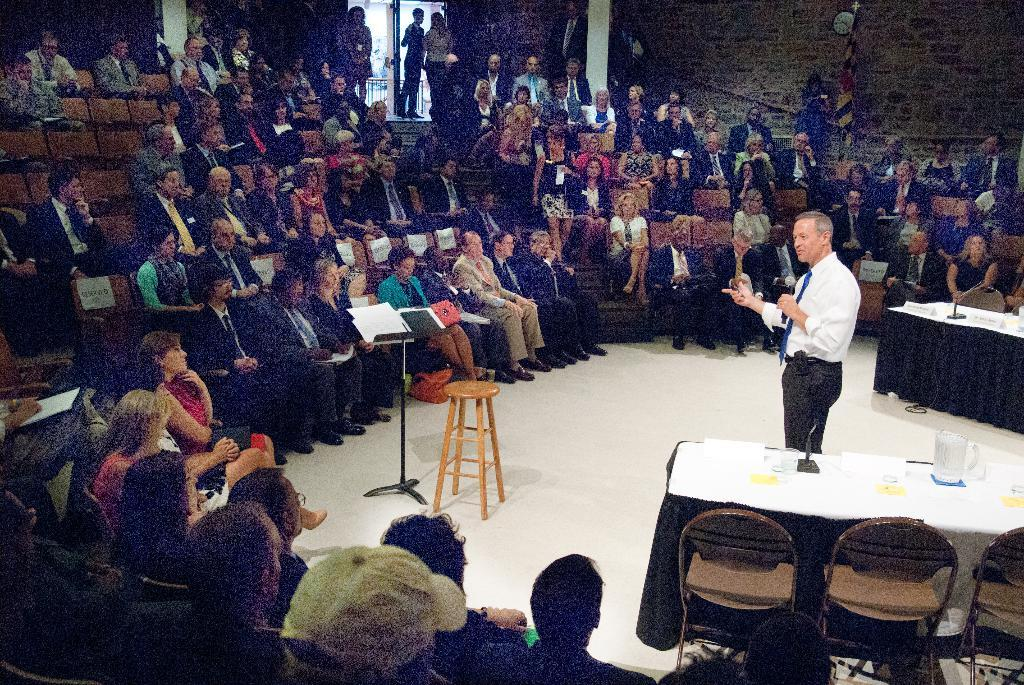What are the people in the image doing? There is a group of people sitting on chairs, and a person standing on the right side. What is the standing person holding? The standing person is holding a microphone. What is the standing person doing with the microphone? The standing person is speaking. Is the writer in the image making any errors while speaking? There is no writer present in the image, and the person speaking is not making any errors. Can you tell me what the dad in the image is doing? There is no dad mentioned in the image; it only features a group of people sitting on chairs and a person standing with a microphone. 